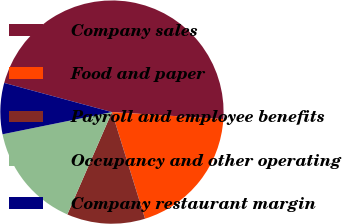Convert chart to OTSL. <chart><loc_0><loc_0><loc_500><loc_500><pie_chart><fcel>Company sales<fcel>Food and paper<fcel>Payroll and employee benefits<fcel>Occupancy and other operating<fcel>Company restaurant margin<nl><fcel>46.79%<fcel>19.21%<fcel>11.33%<fcel>15.27%<fcel>7.39%<nl></chart> 